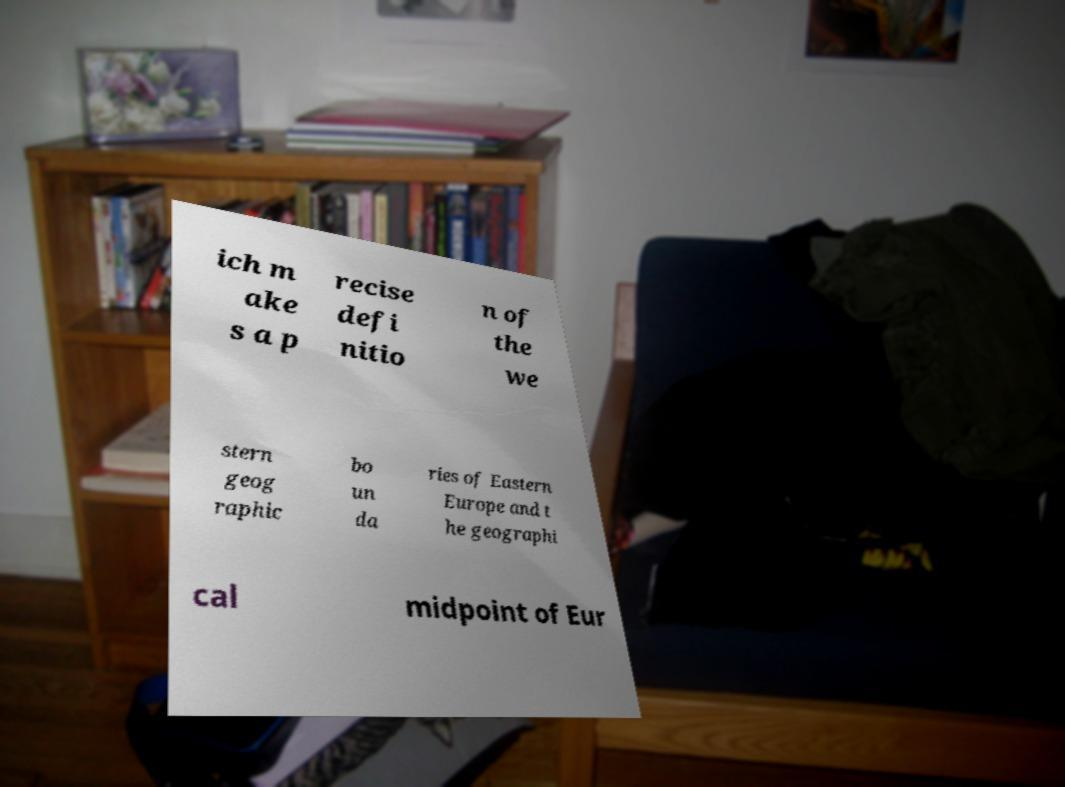Please read and relay the text visible in this image. What does it say? ich m ake s a p recise defi nitio n of the we stern geog raphic bo un da ries of Eastern Europe and t he geographi cal midpoint of Eur 